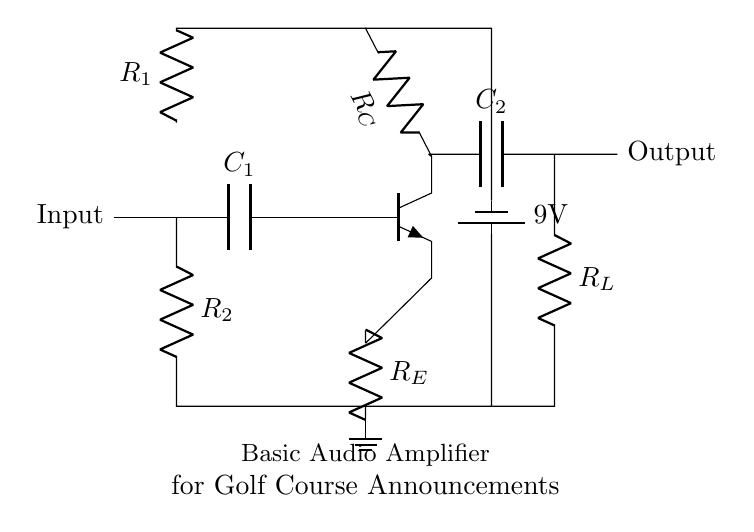what type of amplifier is represented in the circuit? The circuit represents a basic audio amplifier, which is indicated by the presence of audio components and configuration suitable for amplifying sound signals.
Answer: audio amplifier what is the voltage supplied by the battery in the circuit? The voltage supplied by the battery, as specified in the circuit, is 9 volts. This can be seen in the section where the battery is labeled.
Answer: 9 volts what does the capacitor C1 do in the circuit? Capacitor C1 acts as a coupling capacitor, allowing AC signals to pass while blocking DC voltage, which is essential for audio applications in amplifiers.
Answer: coupling capacitor what is the role of resistor R_E in the circuit? Resistor R_E is the emitter resistor, which stabilizes the operating point of the transistor by providing negative feedback, enhancing stability and linearity in amplification.
Answer: emitter resistor how many resistors are present in the circuit? The circuit contains three resistors: R_E, R_C, and R_1, R_2, which are clearly labeled in the circuit diagram.
Answer: three what is the purpose of the load resistor R_L? The load resistor R_L is connected to the output and serves to convert the amplified current into a usable voltage for output, typically connecting to the speaker or announcement system.
Answer: convert current to voltage what happens to the audio signal after it passes through capacitor C2? After passing through capacitor C2, the audio signal is freed from any DC component, allowing it to be sent as a clean audio signal to the output.
Answer: clean audio signal 